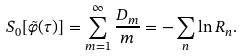Convert formula to latex. <formula><loc_0><loc_0><loc_500><loc_500>S _ { 0 } [ \tilde { \varphi } ( \tau ) ] = \sum _ { m = 1 } ^ { \infty } \frac { D _ { m } } { m } = - \sum _ { n } \ln R _ { n } .</formula> 